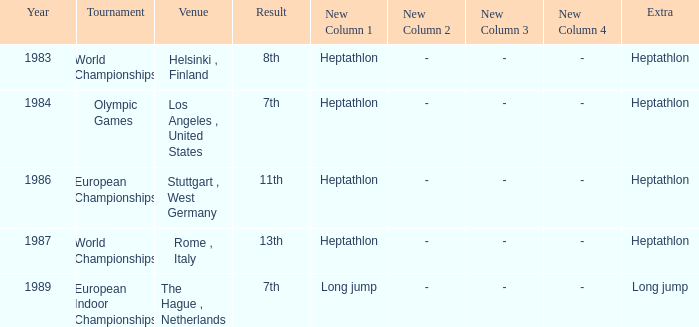Where was the 1984 Olympics hosted? Olympic Games. 